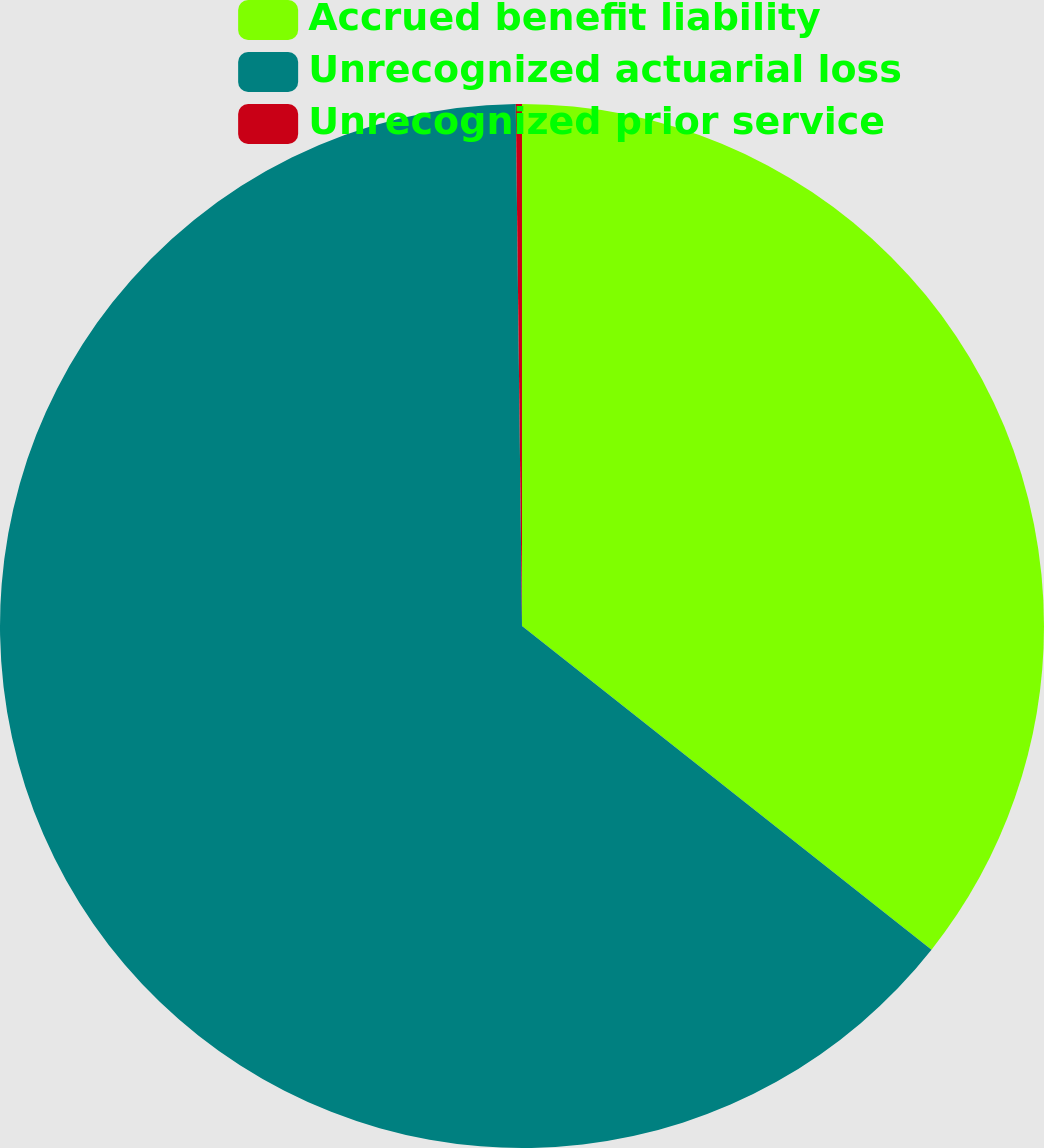Convert chart to OTSL. <chart><loc_0><loc_0><loc_500><loc_500><pie_chart><fcel>Accrued benefit liability<fcel>Unrecognized actuarial loss<fcel>Unrecognized prior service<nl><fcel>35.65%<fcel>64.17%<fcel>0.19%<nl></chart> 